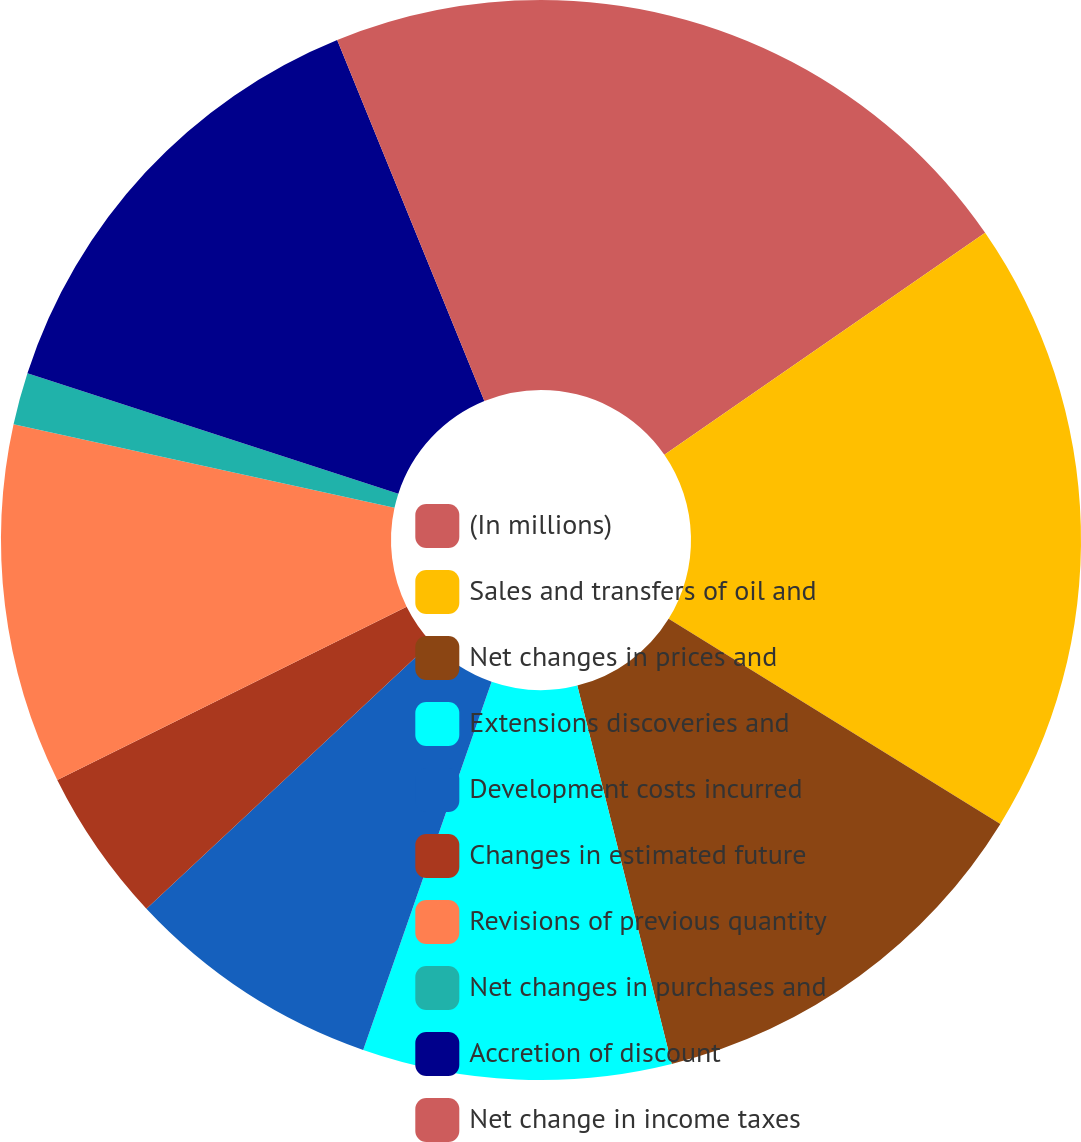<chart> <loc_0><loc_0><loc_500><loc_500><pie_chart><fcel>(In millions)<fcel>Sales and transfers of oil and<fcel>Net changes in prices and<fcel>Extensions discoveries and<fcel>Development costs incurred<fcel>Changes in estimated future<fcel>Revisions of previous quantity<fcel>Net changes in purchases and<fcel>Accretion of discount<fcel>Net change in income taxes<nl><fcel>15.37%<fcel>18.44%<fcel>12.3%<fcel>9.23%<fcel>7.7%<fcel>4.63%<fcel>10.77%<fcel>1.56%<fcel>13.84%<fcel>6.16%<nl></chart> 